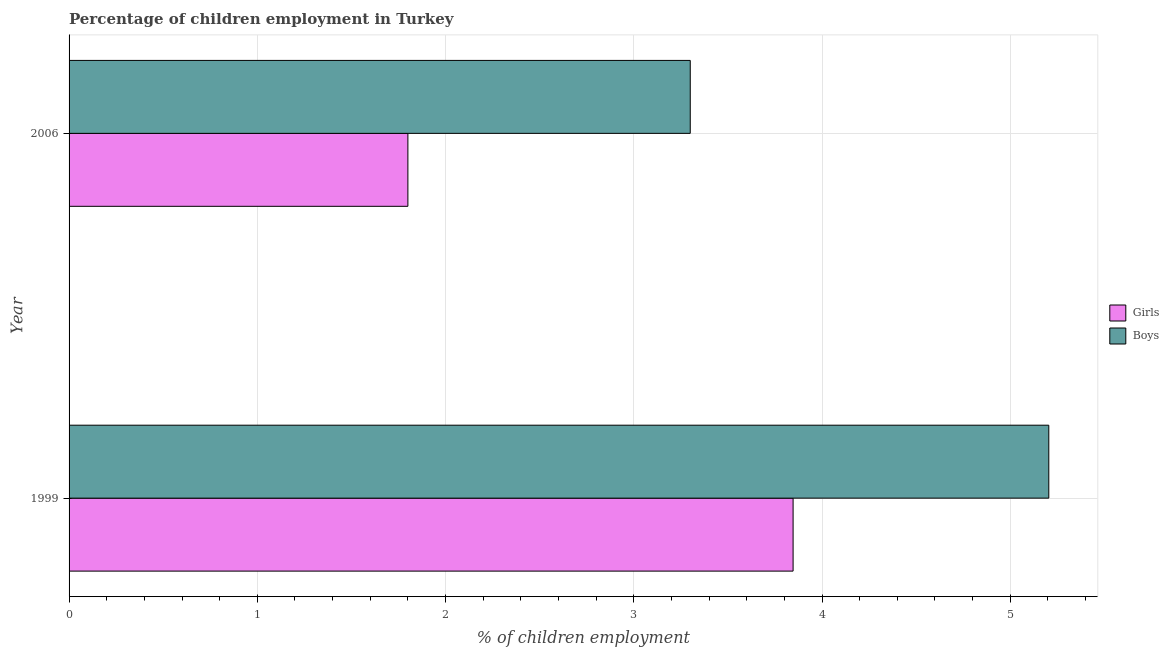Are the number of bars per tick equal to the number of legend labels?
Make the answer very short. Yes. Are the number of bars on each tick of the Y-axis equal?
Provide a short and direct response. Yes. What is the label of the 1st group of bars from the top?
Provide a short and direct response. 2006. What is the percentage of employed girls in 2006?
Make the answer very short. 1.8. Across all years, what is the maximum percentage of employed boys?
Keep it short and to the point. 5.2. Across all years, what is the minimum percentage of employed girls?
Give a very brief answer. 1.8. What is the total percentage of employed boys in the graph?
Offer a terse response. 8.5. What is the difference between the percentage of employed boys in 1999 and that in 2006?
Keep it short and to the point. 1.91. What is the difference between the percentage of employed girls in 2006 and the percentage of employed boys in 1999?
Your answer should be very brief. -3.4. What is the average percentage of employed boys per year?
Keep it short and to the point. 4.25. In the year 2006, what is the difference between the percentage of employed girls and percentage of employed boys?
Provide a short and direct response. -1.5. In how many years, is the percentage of employed boys greater than 4.2 %?
Your response must be concise. 1. What is the ratio of the percentage of employed girls in 1999 to that in 2006?
Your answer should be very brief. 2.14. Is the percentage of employed boys in 1999 less than that in 2006?
Offer a terse response. No. Is the difference between the percentage of employed boys in 1999 and 2006 greater than the difference between the percentage of employed girls in 1999 and 2006?
Your response must be concise. No. In how many years, is the percentage of employed boys greater than the average percentage of employed boys taken over all years?
Your answer should be very brief. 1. What does the 1st bar from the top in 2006 represents?
Offer a terse response. Boys. What does the 2nd bar from the bottom in 1999 represents?
Offer a very short reply. Boys. What is the difference between two consecutive major ticks on the X-axis?
Give a very brief answer. 1. Are the values on the major ticks of X-axis written in scientific E-notation?
Your response must be concise. No. Does the graph contain any zero values?
Make the answer very short. No. What is the title of the graph?
Your answer should be very brief. Percentage of children employment in Turkey. What is the label or title of the X-axis?
Keep it short and to the point. % of children employment. What is the label or title of the Y-axis?
Ensure brevity in your answer.  Year. What is the % of children employment in Girls in 1999?
Make the answer very short. 3.85. What is the % of children employment of Boys in 1999?
Ensure brevity in your answer.  5.2. What is the % of children employment in Girls in 2006?
Your answer should be very brief. 1.8. What is the % of children employment in Boys in 2006?
Provide a short and direct response. 3.3. Across all years, what is the maximum % of children employment of Girls?
Keep it short and to the point. 3.85. Across all years, what is the maximum % of children employment in Boys?
Make the answer very short. 5.2. Across all years, what is the minimum % of children employment in Girls?
Make the answer very short. 1.8. What is the total % of children employment in Girls in the graph?
Keep it short and to the point. 5.65. What is the total % of children employment of Boys in the graph?
Give a very brief answer. 8.5. What is the difference between the % of children employment of Girls in 1999 and that in 2006?
Provide a short and direct response. 2.05. What is the difference between the % of children employment of Boys in 1999 and that in 2006?
Your response must be concise. 1.9. What is the difference between the % of children employment in Girls in 1999 and the % of children employment in Boys in 2006?
Provide a short and direct response. 0.55. What is the average % of children employment of Girls per year?
Provide a succinct answer. 2.82. What is the average % of children employment in Boys per year?
Provide a succinct answer. 4.25. In the year 1999, what is the difference between the % of children employment in Girls and % of children employment in Boys?
Your answer should be compact. -1.36. In the year 2006, what is the difference between the % of children employment of Girls and % of children employment of Boys?
Keep it short and to the point. -1.5. What is the ratio of the % of children employment of Girls in 1999 to that in 2006?
Make the answer very short. 2.14. What is the ratio of the % of children employment in Boys in 1999 to that in 2006?
Provide a short and direct response. 1.58. What is the difference between the highest and the second highest % of children employment in Girls?
Provide a short and direct response. 2.05. What is the difference between the highest and the second highest % of children employment in Boys?
Provide a short and direct response. 1.9. What is the difference between the highest and the lowest % of children employment of Girls?
Your answer should be very brief. 2.05. What is the difference between the highest and the lowest % of children employment of Boys?
Your response must be concise. 1.9. 